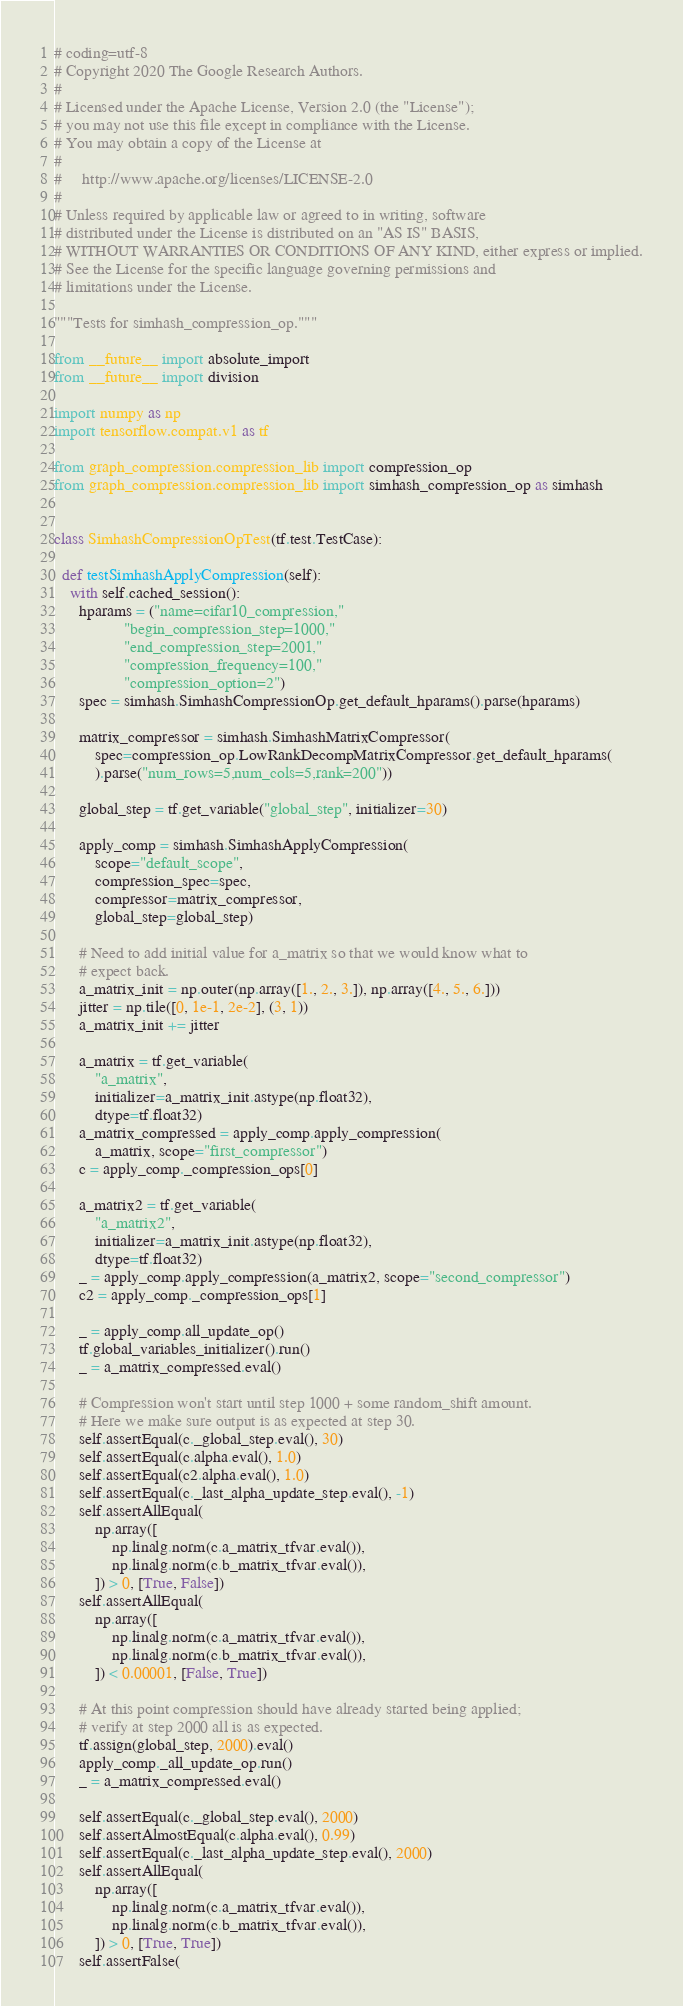Convert code to text. <code><loc_0><loc_0><loc_500><loc_500><_Python_># coding=utf-8
# Copyright 2020 The Google Research Authors.
#
# Licensed under the Apache License, Version 2.0 (the "License");
# you may not use this file except in compliance with the License.
# You may obtain a copy of the License at
#
#     http://www.apache.org/licenses/LICENSE-2.0
#
# Unless required by applicable law or agreed to in writing, software
# distributed under the License is distributed on an "AS IS" BASIS,
# WITHOUT WARRANTIES OR CONDITIONS OF ANY KIND, either express or implied.
# See the License for the specific language governing permissions and
# limitations under the License.

"""Tests for simhash_compression_op."""

from __future__ import absolute_import
from __future__ import division

import numpy as np
import tensorflow.compat.v1 as tf

from graph_compression.compression_lib import compression_op
from graph_compression.compression_lib import simhash_compression_op as simhash


class SimhashCompressionOpTest(tf.test.TestCase):

  def testSimhashApplyCompression(self):
    with self.cached_session():
      hparams = ("name=cifar10_compression,"
                 "begin_compression_step=1000,"
                 "end_compression_step=2001,"
                 "compression_frequency=100,"
                 "compression_option=2")
      spec = simhash.SimhashCompressionOp.get_default_hparams().parse(hparams)

      matrix_compressor = simhash.SimhashMatrixCompressor(
          spec=compression_op.LowRankDecompMatrixCompressor.get_default_hparams(
          ).parse("num_rows=5,num_cols=5,rank=200"))

      global_step = tf.get_variable("global_step", initializer=30)

      apply_comp = simhash.SimhashApplyCompression(
          scope="default_scope",
          compression_spec=spec,
          compressor=matrix_compressor,
          global_step=global_step)

      # Need to add initial value for a_matrix so that we would know what to
      # expect back.
      a_matrix_init = np.outer(np.array([1., 2., 3.]), np.array([4., 5., 6.]))
      jitter = np.tile([0, 1e-1, 2e-2], (3, 1))
      a_matrix_init += jitter

      a_matrix = tf.get_variable(
          "a_matrix",
          initializer=a_matrix_init.astype(np.float32),
          dtype=tf.float32)
      a_matrix_compressed = apply_comp.apply_compression(
          a_matrix, scope="first_compressor")
      c = apply_comp._compression_ops[0]

      a_matrix2 = tf.get_variable(
          "a_matrix2",
          initializer=a_matrix_init.astype(np.float32),
          dtype=tf.float32)
      _ = apply_comp.apply_compression(a_matrix2, scope="second_compressor")
      c2 = apply_comp._compression_ops[1]

      _ = apply_comp.all_update_op()
      tf.global_variables_initializer().run()
      _ = a_matrix_compressed.eval()

      # Compression won't start until step 1000 + some random_shift amount.
      # Here we make sure output is as expected at step 30.
      self.assertEqual(c._global_step.eval(), 30)
      self.assertEqual(c.alpha.eval(), 1.0)
      self.assertEqual(c2.alpha.eval(), 1.0)
      self.assertEqual(c._last_alpha_update_step.eval(), -1)
      self.assertAllEqual(
          np.array([
              np.linalg.norm(c.a_matrix_tfvar.eval()),
              np.linalg.norm(c.b_matrix_tfvar.eval()),
          ]) > 0, [True, False])
      self.assertAllEqual(
          np.array([
              np.linalg.norm(c.a_matrix_tfvar.eval()),
              np.linalg.norm(c.b_matrix_tfvar.eval()),
          ]) < 0.00001, [False, True])

      # At this point compression should have already started being applied;
      # verify at step 2000 all is as expected.
      tf.assign(global_step, 2000).eval()
      apply_comp._all_update_op.run()
      _ = a_matrix_compressed.eval()

      self.assertEqual(c._global_step.eval(), 2000)
      self.assertAlmostEqual(c.alpha.eval(), 0.99)
      self.assertEqual(c._last_alpha_update_step.eval(), 2000)
      self.assertAllEqual(
          np.array([
              np.linalg.norm(c.a_matrix_tfvar.eval()),
              np.linalg.norm(c.b_matrix_tfvar.eval()),
          ]) > 0, [True, True])
      self.assertFalse(</code> 